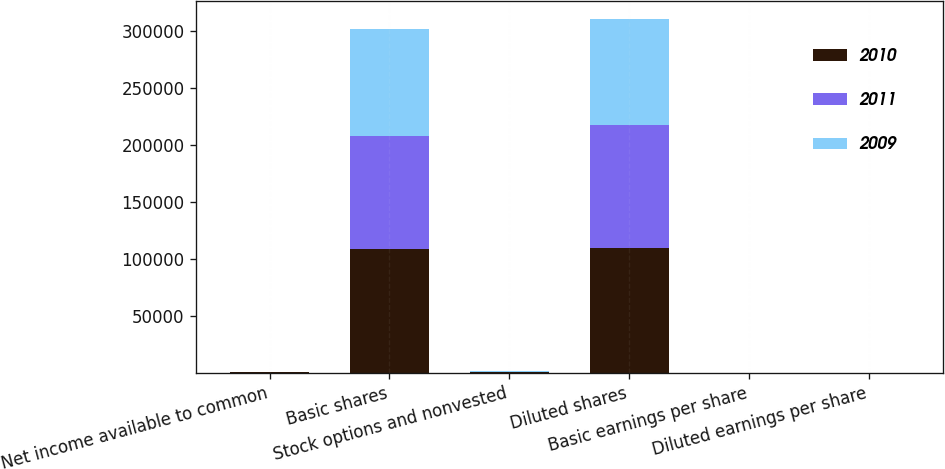Convert chart. <chart><loc_0><loc_0><loc_500><loc_500><stacked_bar_chart><ecel><fcel>Net income available to common<fcel>Basic shares<fcel>Stock options and nonvested<fcel>Diluted shares<fcel>Basic earnings per share<fcel>Diluted earnings per share<nl><fcel>2010<fcel>330<fcel>108208<fcel>377<fcel>109830<fcel>3.04<fcel>3<nl><fcel>2011<fcel>180<fcel>100054<fcel>480<fcel>107534<fcel>1.69<fcel>1.67<nl><fcel>2009<fcel>56.1<fcel>93145<fcel>504<fcel>93649<fcel>0.6<fcel>0.6<nl></chart> 